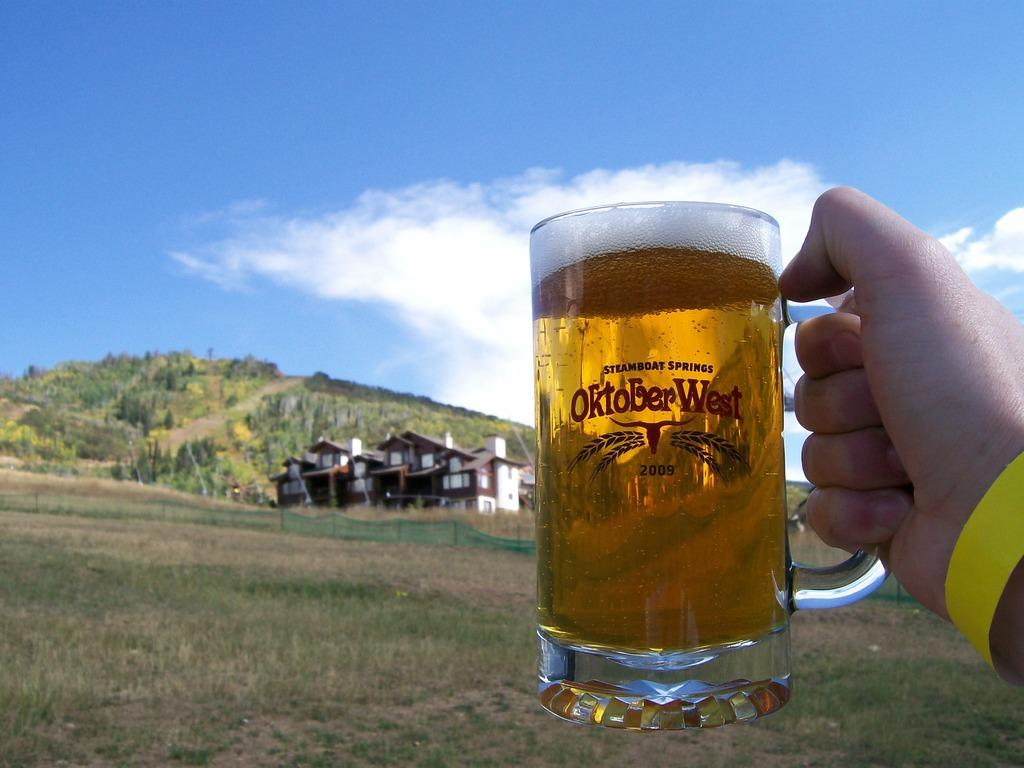<image>
Relay a brief, clear account of the picture shown. A hand holding a glass mug of beer that says Oktoberfest. 